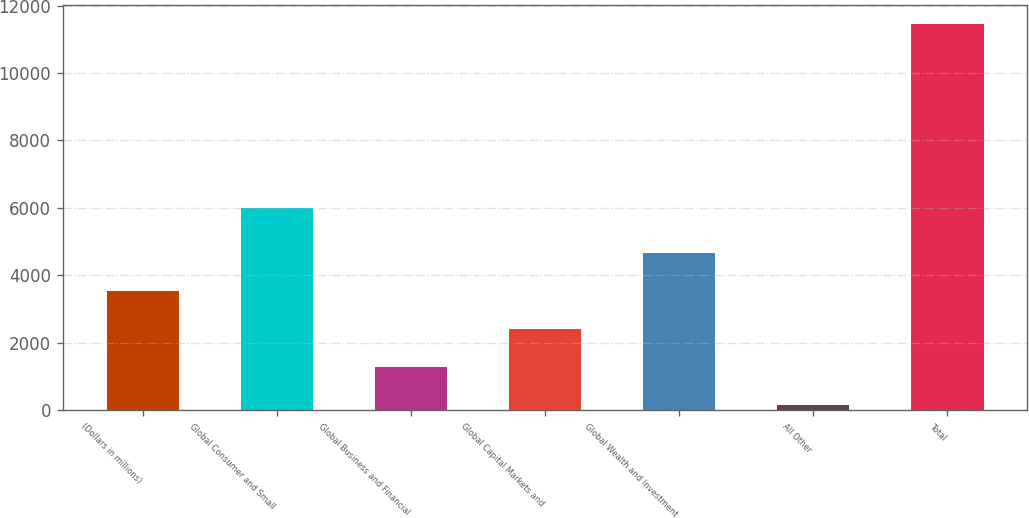<chart> <loc_0><loc_0><loc_500><loc_500><bar_chart><fcel>(Dollars in millions)<fcel>Global Consumer and Small<fcel>Global Business and Financial<fcel>Global Capital Markets and<fcel>Global Wealth and Investment<fcel>All Other<fcel>Total<nl><fcel>3531<fcel>6000<fcel>1267<fcel>2399<fcel>4663<fcel>135<fcel>11455<nl></chart> 